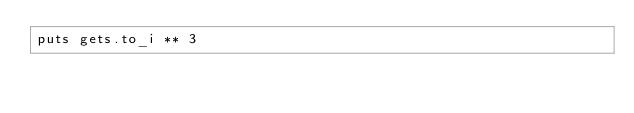Convert code to text. <code><loc_0><loc_0><loc_500><loc_500><_Ruby_>puts gets.to_i ** 3</code> 